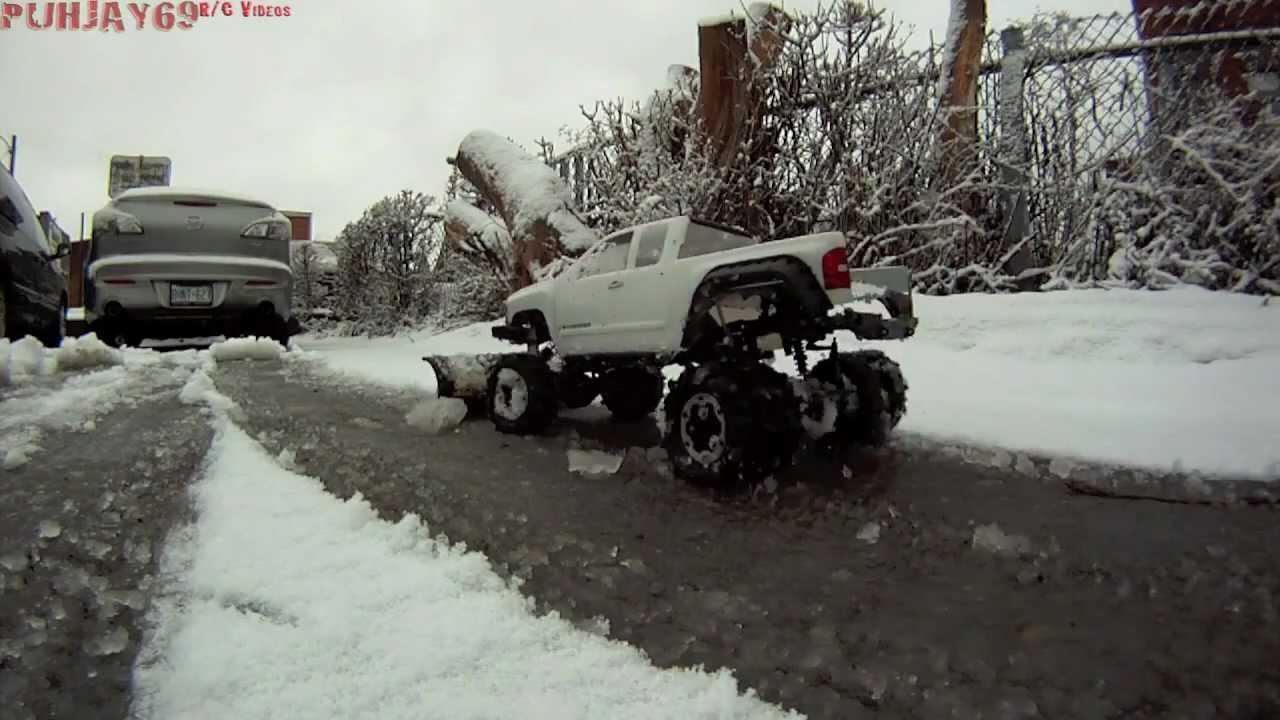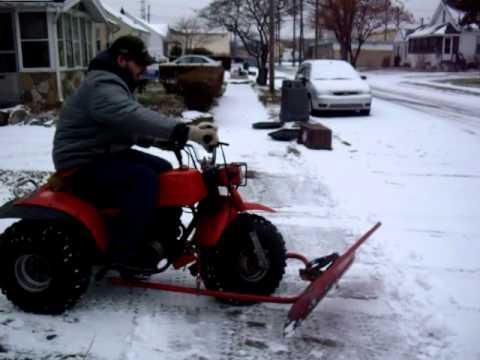The first image is the image on the left, the second image is the image on the right. For the images displayed, is the sentence "There is at least one person in the image on the right." factually correct? Answer yes or no. Yes. 